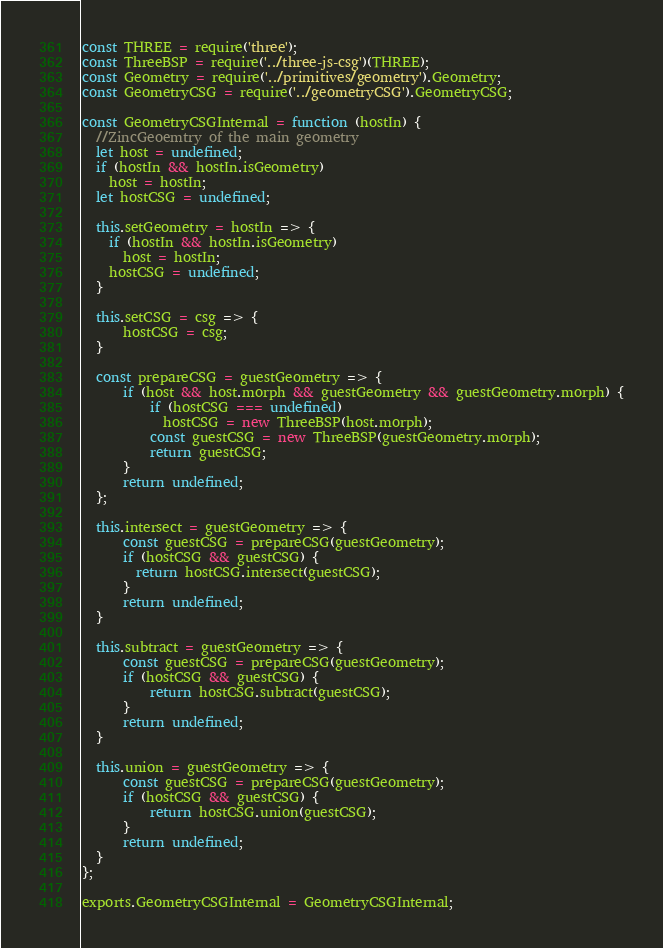<code> <loc_0><loc_0><loc_500><loc_500><_JavaScript_>const THREE = require('three');
const ThreeBSP = require('../three-js-csg')(THREE);
const Geometry = require('../primitives/geometry').Geometry;
const GeometryCSG = require('../geometryCSG').GeometryCSG;

const GeometryCSGInternal = function (hostIn) {
  //ZincGeoemtry of the main geometry
  let host = undefined;
  if (hostIn && hostIn.isGeometry)
    host = hostIn;
  let hostCSG = undefined;
  
  this.setGeometry = hostIn => {
    if (hostIn && hostIn.isGeometry)
	  host = hostIn;
    hostCSG = undefined;
  }
  
  this.setCSG = csg => {
	  hostCSG = csg;
  }
  
  const prepareCSG = guestGeometry => {
	  if (host && host.morph && guestGeometry && guestGeometry.morph) {
	      if (hostCSG === undefined)
	        hostCSG = new ThreeBSP(host.morph);
	      const guestCSG = new ThreeBSP(guestGeometry.morph);
	      return guestCSG;
	  }
	  return undefined;
  };
  
  this.intersect = guestGeometry => {
	  const guestCSG = prepareCSG(guestGeometry);
	  if (hostCSG && guestCSG) {
	    return hostCSG.intersect(guestCSG);
	  }
	  return undefined;
  }
  
  this.subtract = guestGeometry => {
	  const guestCSG = prepareCSG(guestGeometry);
	  if (hostCSG && guestCSG) {
		  return hostCSG.subtract(guestCSG);
	  }
	  return undefined;
  }
  
  this.union = guestGeometry => {
	  const guestCSG = prepareCSG(guestGeometry);
	  if (hostCSG && guestCSG) {
		  return hostCSG.union(guestCSG);
	  }
	  return undefined;
  }
};

exports.GeometryCSGInternal = GeometryCSGInternal;
</code> 